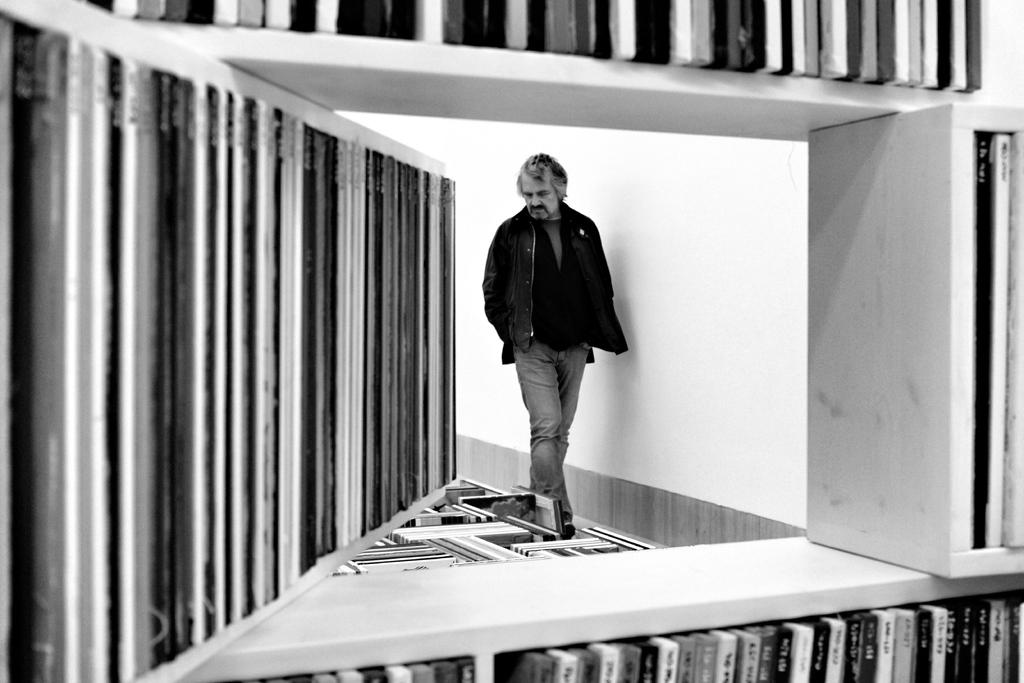Who is present in the image? There is a man in the image. What is the man doing in the image? The man is walking. What type of clothing is the man wearing in the image? The man is wearing a coat and trousers. What can be seen at the bottom of the image? There are books in a rack at the bottom of the image. What type of crime is being committed in the image? There is no crime being committed in the image; it simply shows a man walking while wearing a coat and trousers. Can you tell me how the man is an expert in space travel in the image? There is no indication in the image that the man is an expert in space travel or that space travel is related to the image. 